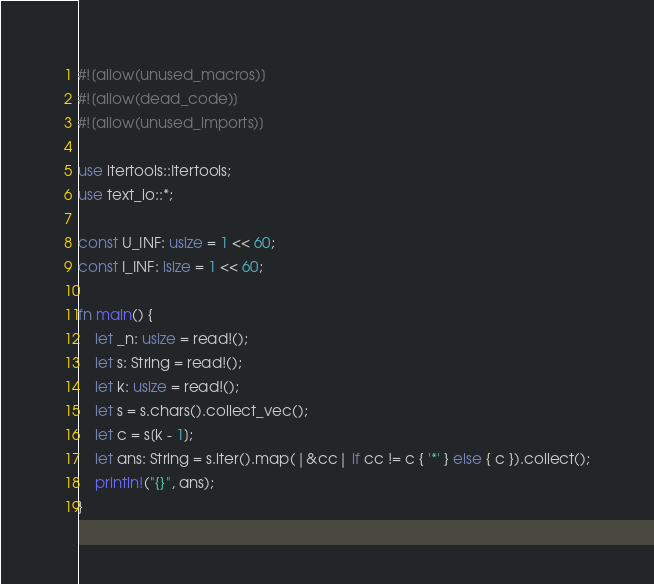Convert code to text. <code><loc_0><loc_0><loc_500><loc_500><_Rust_>#![allow(unused_macros)]
#![allow(dead_code)]
#![allow(unused_imports)]

use itertools::Itertools;
use text_io::*;

const U_INF: usize = 1 << 60;
const I_INF: isize = 1 << 60;

fn main() {
    let _n: usize = read!();
    let s: String = read!();
    let k: usize = read!();
    let s = s.chars().collect_vec();
    let c = s[k - 1];
    let ans: String = s.iter().map(|&cc| if cc != c { '*' } else { c }).collect();
    println!("{}", ans);
}
</code> 